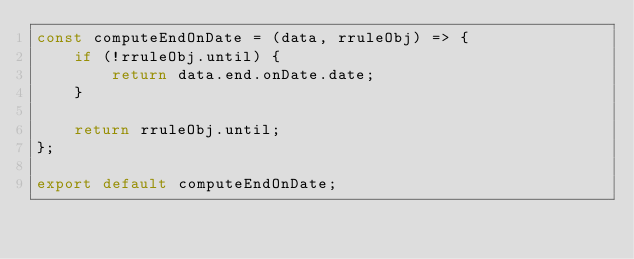Convert code to text. <code><loc_0><loc_0><loc_500><loc_500><_JavaScript_>const computeEndOnDate = (data, rruleObj) => {
    if (!rruleObj.until) {
        return data.end.onDate.date;
    }

    return rruleObj.until;
};

export default computeEndOnDate;
</code> 